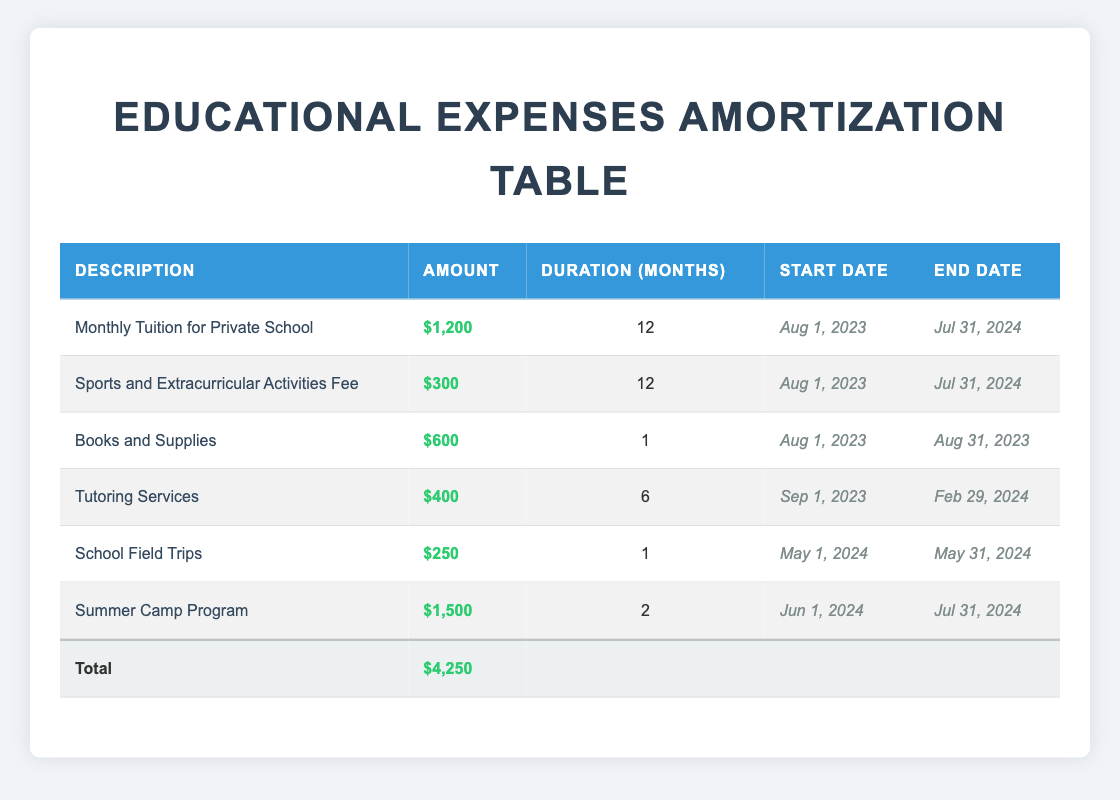What is the total educational expense for the year? The table lists six educational expenses. Adding them up gives: 1200 + 300 + 600 + 400 + 250 + 1500 = 4250. Therefore, the total educational expense is $4,250.
Answer: 4250 How many months will the Monthly Tuition for Private School be paid? The Monthly Tuition for Private School is for 12 months, as specified in the duration column of the table.
Answer: 12 months Is the amount for Sports and Extracurricular Activities Fee higher than the amount for Tutoring Services? The amount for Sports and Extracurricular Activities Fee is $300, while Tutoring Services is $400. Therefore, 300 is not higher than 400.
Answer: No What is the duration of the Summer Camp Program? The duration of the Summer Camp Program is listed as 2 months in the duration column of the table.
Answer: 2 months What is the total amount allocated for tutoring services and sports activities combined? Tutoring Services is $400 and Sports and Extracurricular Activities Fee is $300. Adding these amounts gives: 400 + 300 = 700. Therefore, the total is $700.
Answer: 700 Is there an expense for books and supplies that extends beyond August 2023? The Books and Supplies expense is $600 for a duration of 1 month, starting from August 1, 2023, and ending August 31, 2023. Therefore, it does not extend beyond August 2023.
Answer: No What is the difference in amounts between the Monthly Tuition for Private School and the Summer Camp Program? The Monthly Tuition is $1200 and the Summer Camp Program is $1500. The difference is calculated as 1500 - 1200 = 300.
Answer: 300 How many total educational expenses are listed in the table? The table lists a total of 6 different educational expenses.
Answer: 6 